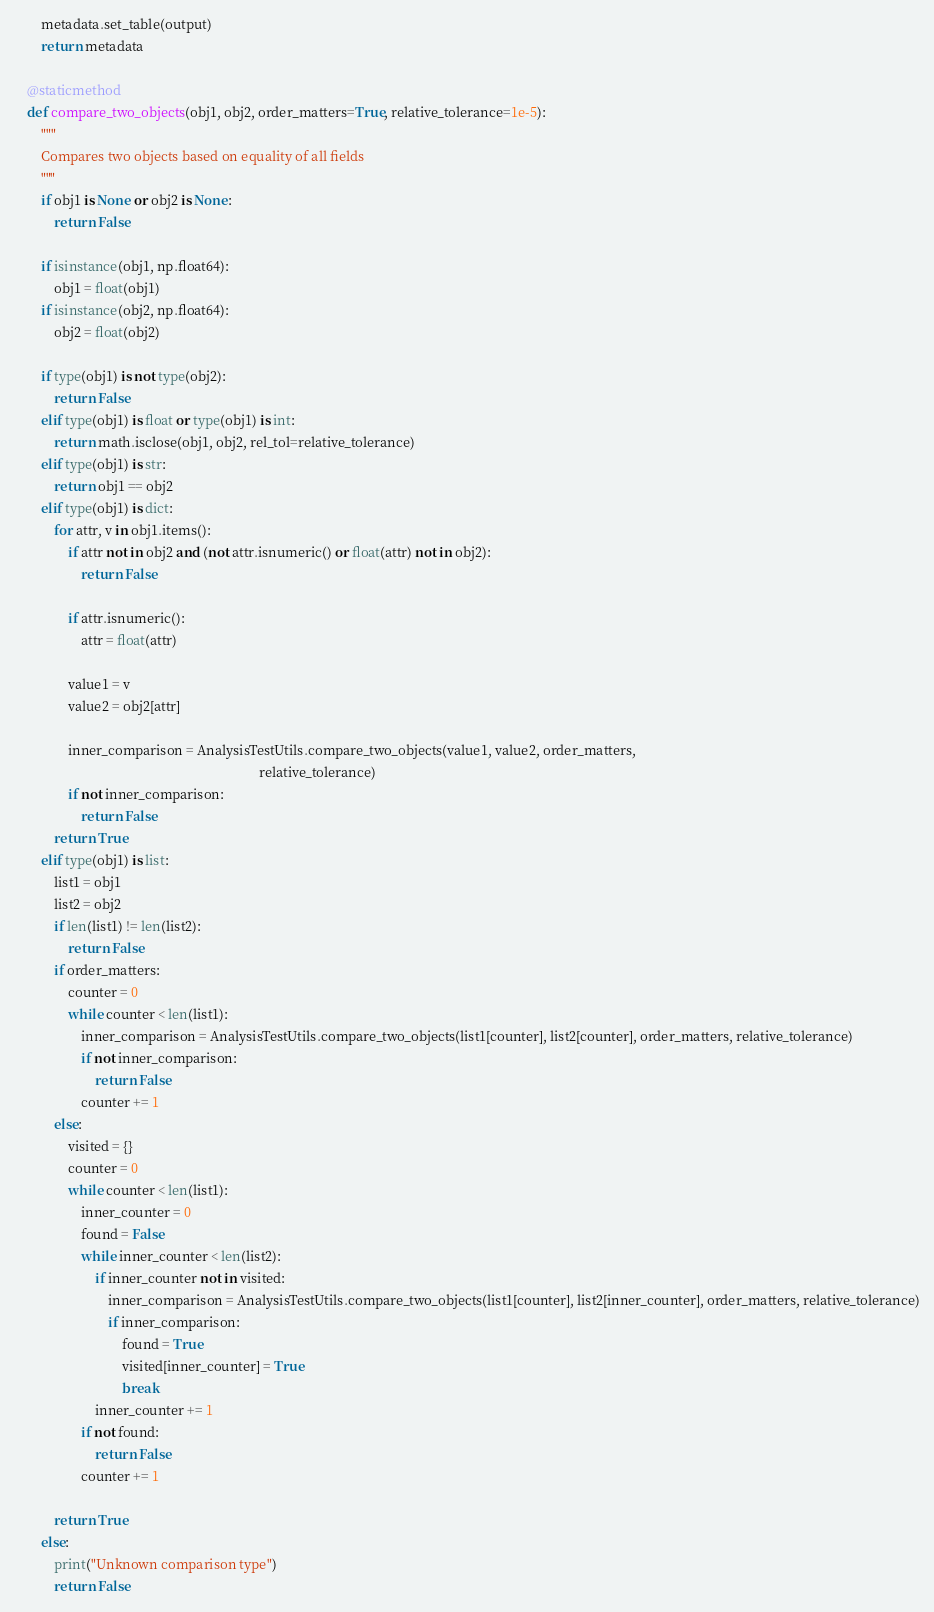Convert code to text. <code><loc_0><loc_0><loc_500><loc_500><_Python_>        metadata.set_table(output)
        return metadata

    @staticmethod
    def compare_two_objects(obj1, obj2, order_matters=True, relative_tolerance=1e-5):
        """
        Compares two objects based on equality of all fields
        """
        if obj1 is None or obj2 is None:
            return False

        if isinstance(obj1, np.float64):
            obj1 = float(obj1)
        if isinstance(obj2, np.float64):
            obj2 = float(obj2)

        if type(obj1) is not type(obj2):
            return False
        elif type(obj1) is float or type(obj1) is int:
            return math.isclose(obj1, obj2, rel_tol=relative_tolerance)
        elif type(obj1) is str:
            return obj1 == obj2
        elif type(obj1) is dict:
            for attr, v in obj1.items():
                if attr not in obj2 and (not attr.isnumeric() or float(attr) not in obj2):
                    return False

                if attr.isnumeric():
                    attr = float(attr)

                value1 = v
                value2 = obj2[attr]

                inner_comparison = AnalysisTestUtils.compare_two_objects(value1, value2, order_matters,
                                                                         relative_tolerance)
                if not inner_comparison:
                    return False
            return True
        elif type(obj1) is list:
            list1 = obj1
            list2 = obj2
            if len(list1) != len(list2):
                return False
            if order_matters:
                counter = 0
                while counter < len(list1):
                    inner_comparison = AnalysisTestUtils.compare_two_objects(list1[counter], list2[counter], order_matters, relative_tolerance)
                    if not inner_comparison:
                        return False
                    counter += 1
            else:
                visited = {}
                counter = 0
                while counter < len(list1):
                    inner_counter = 0
                    found = False
                    while inner_counter < len(list2):
                        if inner_counter not in visited:
                            inner_comparison = AnalysisTestUtils.compare_two_objects(list1[counter], list2[inner_counter], order_matters, relative_tolerance)
                            if inner_comparison:
                                found = True
                                visited[inner_counter] = True
                                break
                        inner_counter += 1
                    if not found:
                        return False
                    counter += 1

            return True
        else:
            print("Unknown comparison type")
            return False

</code> 